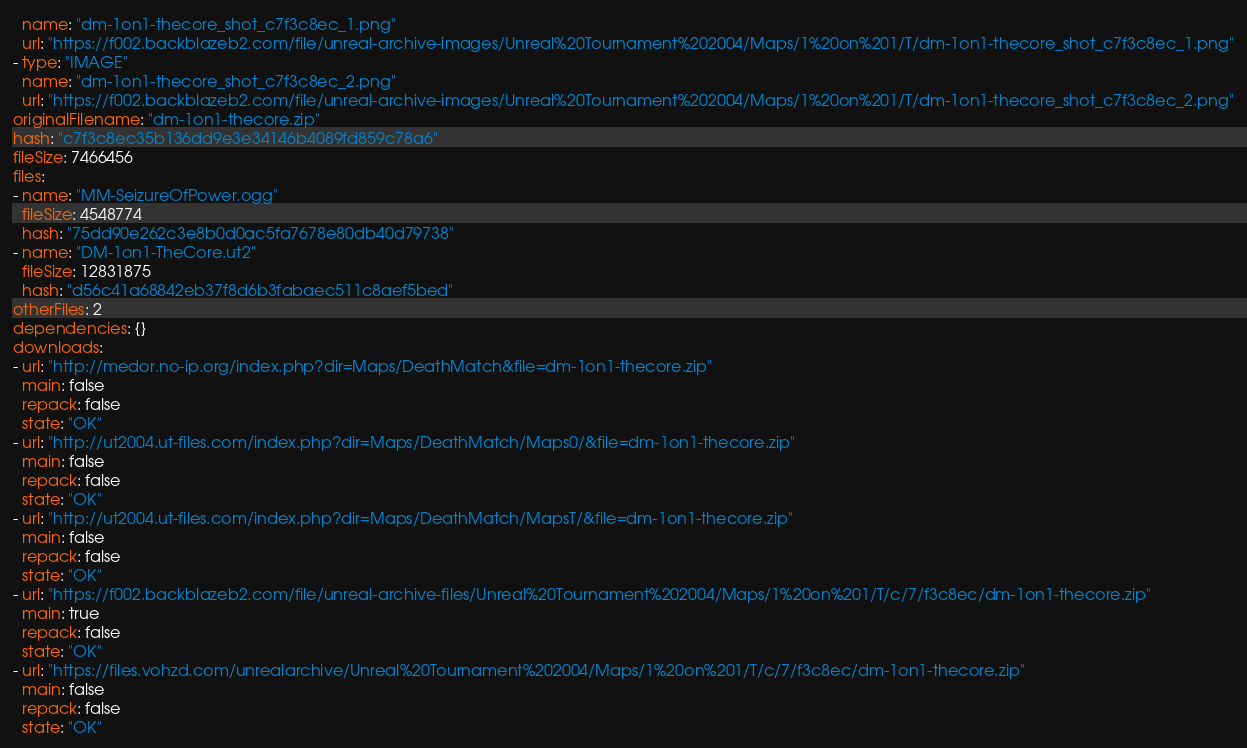<code> <loc_0><loc_0><loc_500><loc_500><_YAML_>  name: "dm-1on1-thecore_shot_c7f3c8ec_1.png"
  url: "https://f002.backblazeb2.com/file/unreal-archive-images/Unreal%20Tournament%202004/Maps/1%20on%201/T/dm-1on1-thecore_shot_c7f3c8ec_1.png"
- type: "IMAGE"
  name: "dm-1on1-thecore_shot_c7f3c8ec_2.png"
  url: "https://f002.backblazeb2.com/file/unreal-archive-images/Unreal%20Tournament%202004/Maps/1%20on%201/T/dm-1on1-thecore_shot_c7f3c8ec_2.png"
originalFilename: "dm-1on1-thecore.zip"
hash: "c7f3c8ec35b136dd9e3e34146b4089fd859c78a6"
fileSize: 7466456
files:
- name: "MM-SeizureOfPower.ogg"
  fileSize: 4548774
  hash: "75dd90e262c3e8b0d0ac5fa7678e80db40d79738"
- name: "DM-1on1-TheCore.ut2"
  fileSize: 12831875
  hash: "d56c41a68842eb37f8d6b3fabaec511c8aef5bed"
otherFiles: 2
dependencies: {}
downloads:
- url: "http://medor.no-ip.org/index.php?dir=Maps/DeathMatch&file=dm-1on1-thecore.zip"
  main: false
  repack: false
  state: "OK"
- url: "http://ut2004.ut-files.com/index.php?dir=Maps/DeathMatch/Maps0/&file=dm-1on1-thecore.zip"
  main: false
  repack: false
  state: "OK"
- url: "http://ut2004.ut-files.com/index.php?dir=Maps/DeathMatch/MapsT/&file=dm-1on1-thecore.zip"
  main: false
  repack: false
  state: "OK"
- url: "https://f002.backblazeb2.com/file/unreal-archive-files/Unreal%20Tournament%202004/Maps/1%20on%201/T/c/7/f3c8ec/dm-1on1-thecore.zip"
  main: true
  repack: false
  state: "OK"
- url: "https://files.vohzd.com/unrealarchive/Unreal%20Tournament%202004/Maps/1%20on%201/T/c/7/f3c8ec/dm-1on1-thecore.zip"
  main: false
  repack: false
  state: "OK"</code> 